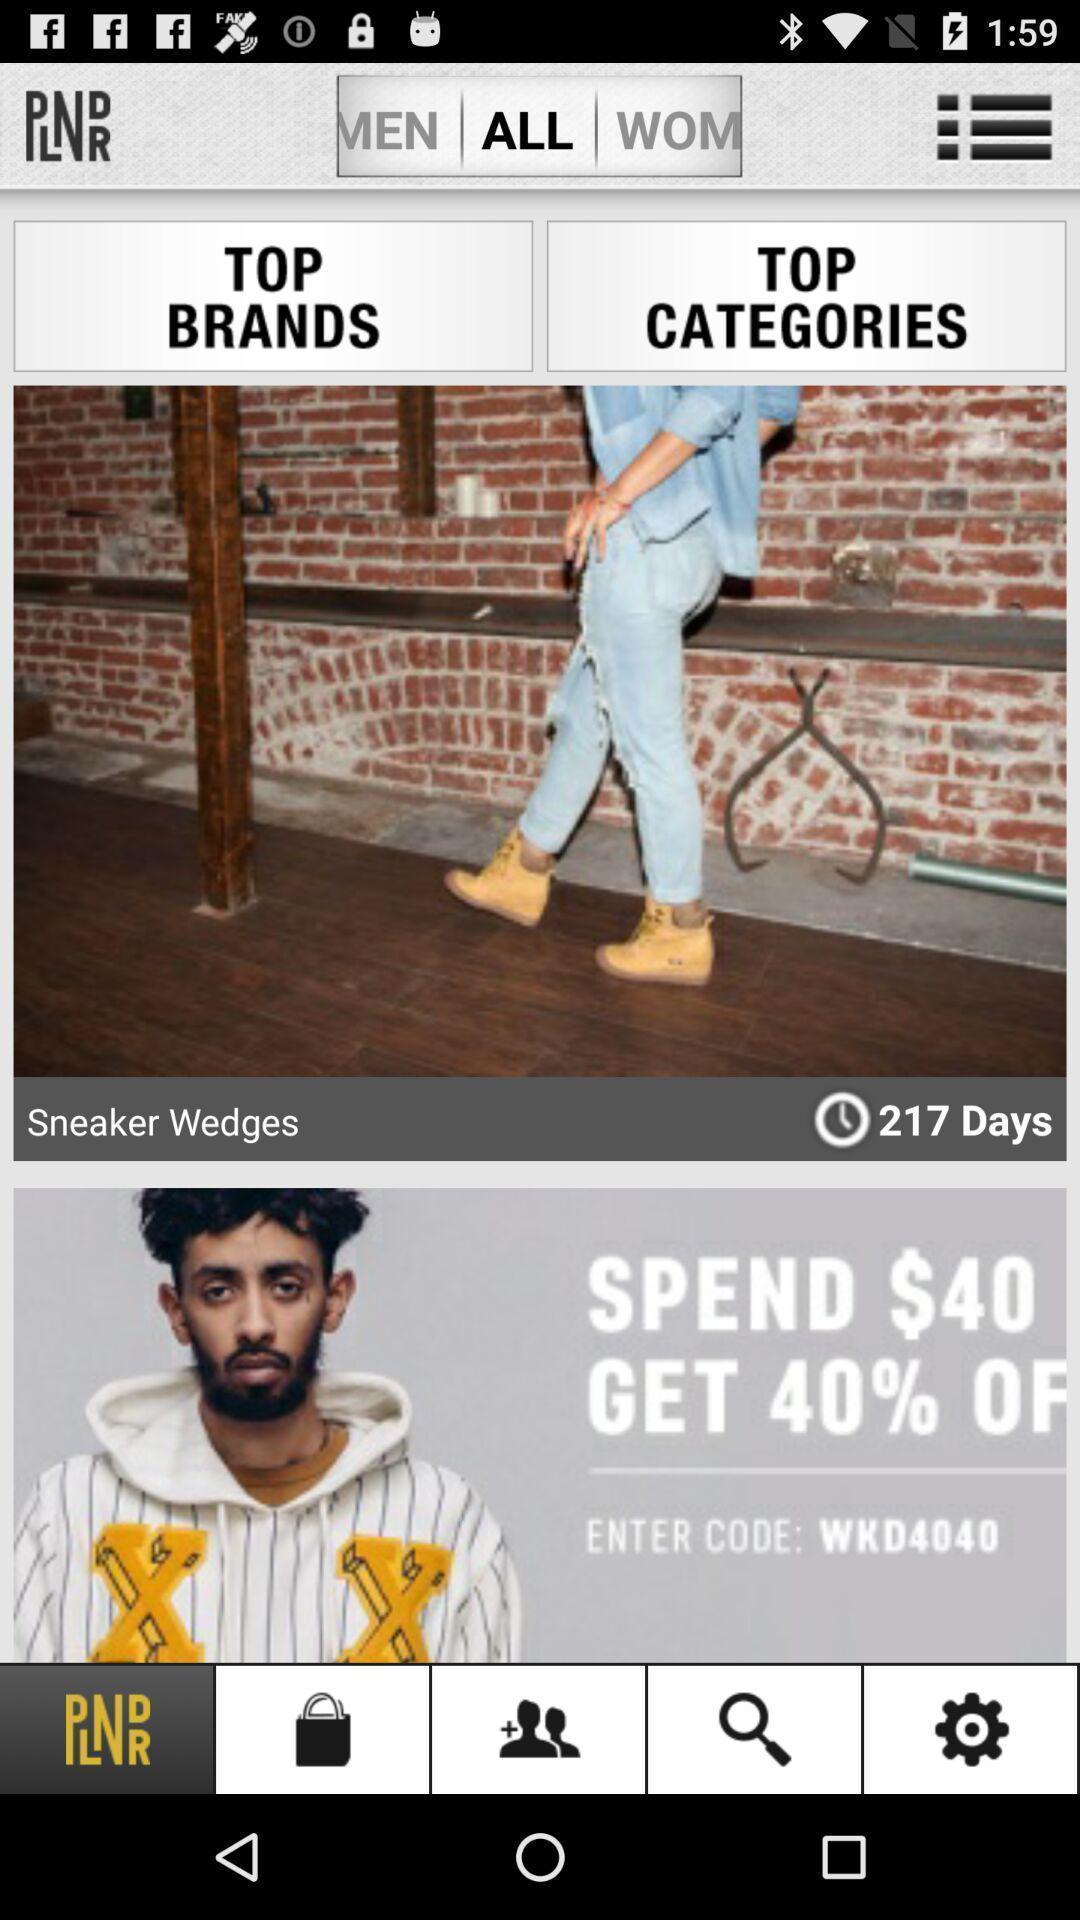Tell me about the visual elements in this screen capture. Page displaying with list of options in the shopping application. 